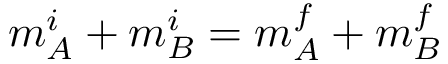Convert formula to latex. <formula><loc_0><loc_0><loc_500><loc_500>m _ { A } ^ { i } + m _ { B } ^ { i } = m _ { A } ^ { f } + m _ { B } ^ { f }</formula> 